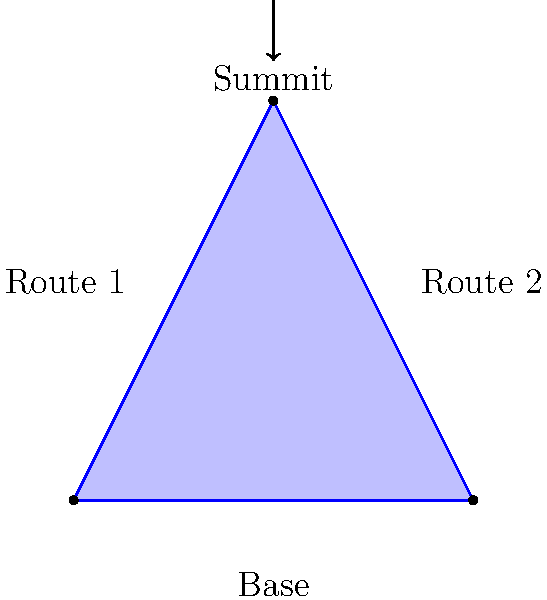Consider a stylized Scottish mountain with two distinct routes to the summit. Three hikers (A, B, and C) plan to climb the mountain, each choosing one of the two routes. How many different ways can the hikers arrange themselves for the ascent, considering the route choices and the order in which they start? Let's approach this step-by-step:

1) First, we need to understand what constitutes a unique arrangement:
   - The route each hiker takes
   - The order in which they start on each route

2) For each hiker, there are 2 choices of routes. So, we start with $2^3 = 8$ possible route combinations.

3) However, for each route combination, we need to consider the order of hikers on each route.

4) Let's break it down by the number of hikers on each route:

   a) All 3 hikers on one route:
      - 2 possibilities (all on Route 1 or all on Route 2)
      - For each, there are 3! = 6 possible orders
      - Total: $2 * 6 = 12$ arrangements

   b) 2 hikers on one route, 1 on the other:
      - 2 possibilities for which route has 2 hikers
      - $\binom{3}{2} = 3$ ways to choose which 2 hikers are together
      - 2! = 2 ways to order the 2 hikers on their route
      - Total: $2 * 3 * 2 = 12$ arrangements

5) Adding these together: $12 + 12 = 24$ total arrangements

This problem relates to the permutation group $S_3$ acting on the set of route choices, demonstrating how group theory concepts apply to real-world scenarios like mountain climbing.
Answer: 24 arrangements 